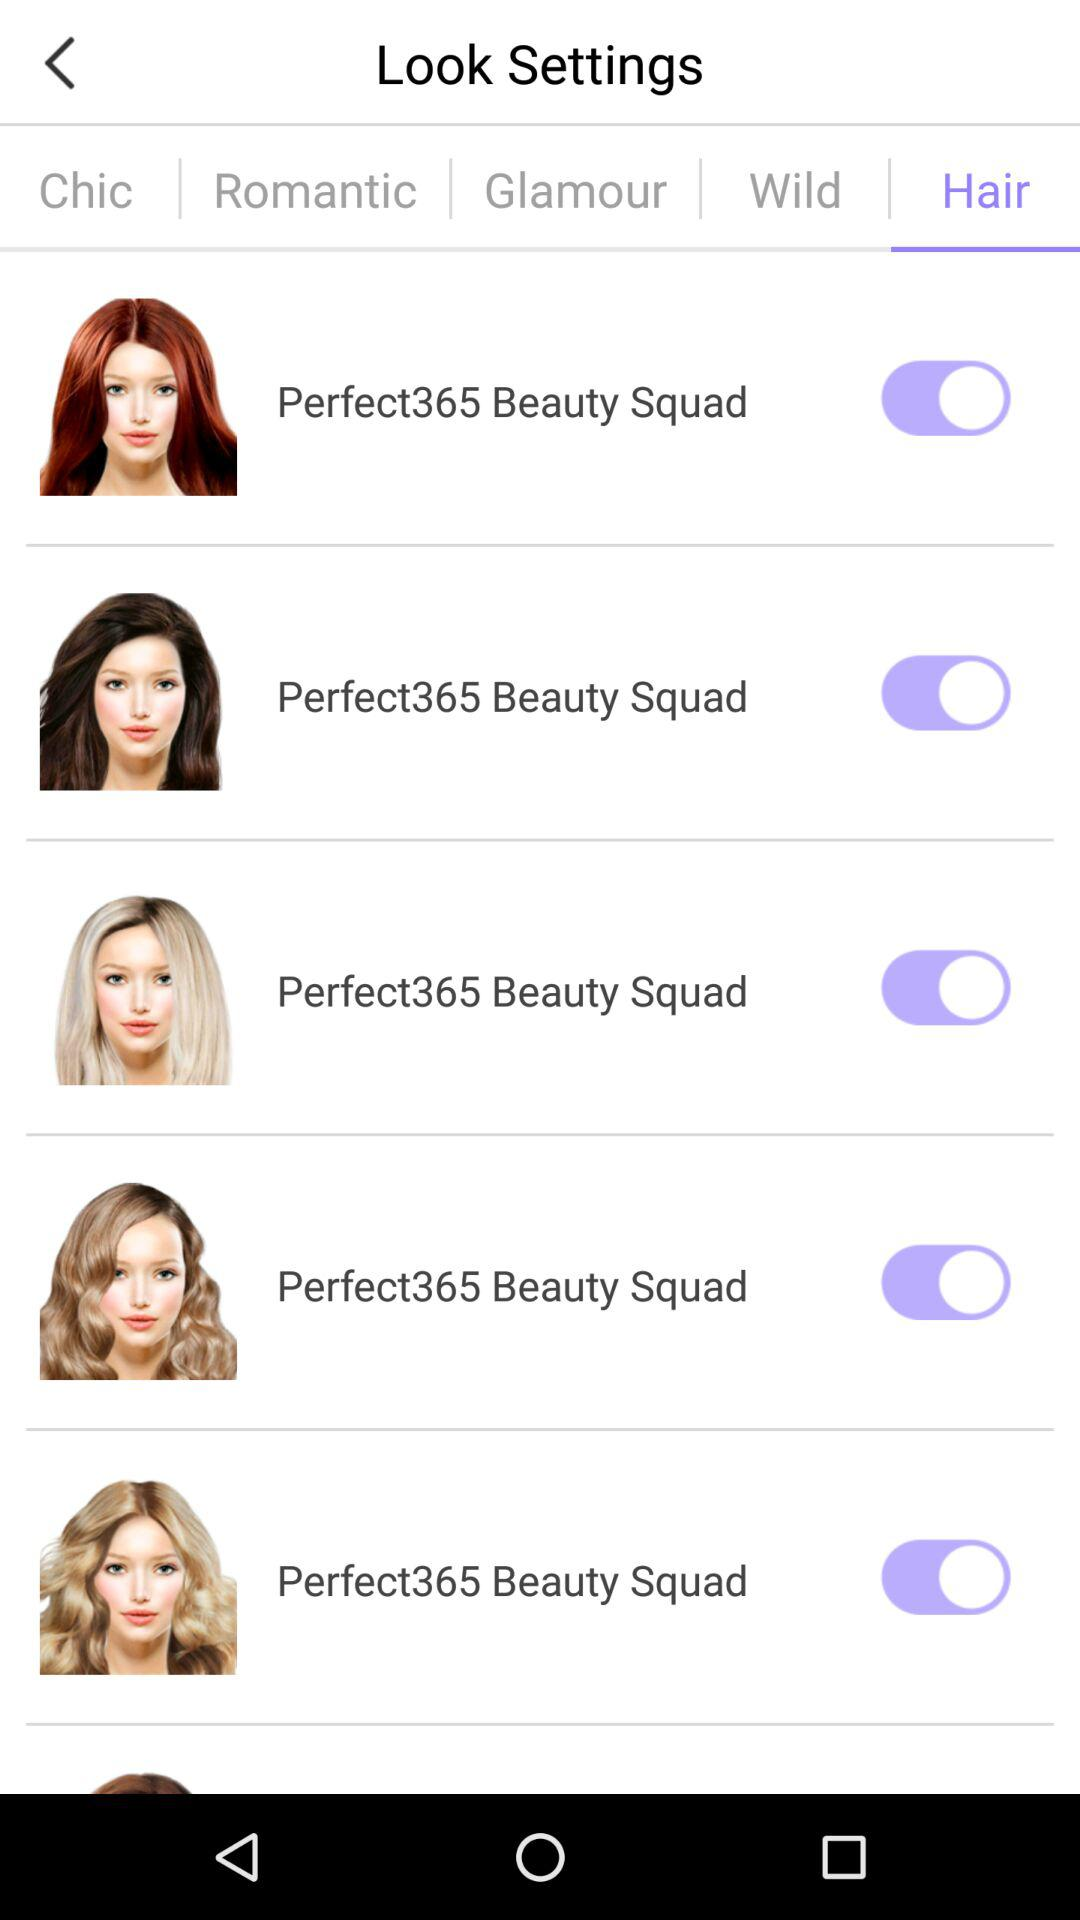What is the status of the "Perfect365 Beauty Squad"? The status of the "Perfect365 Beauty Squad" is "on". 